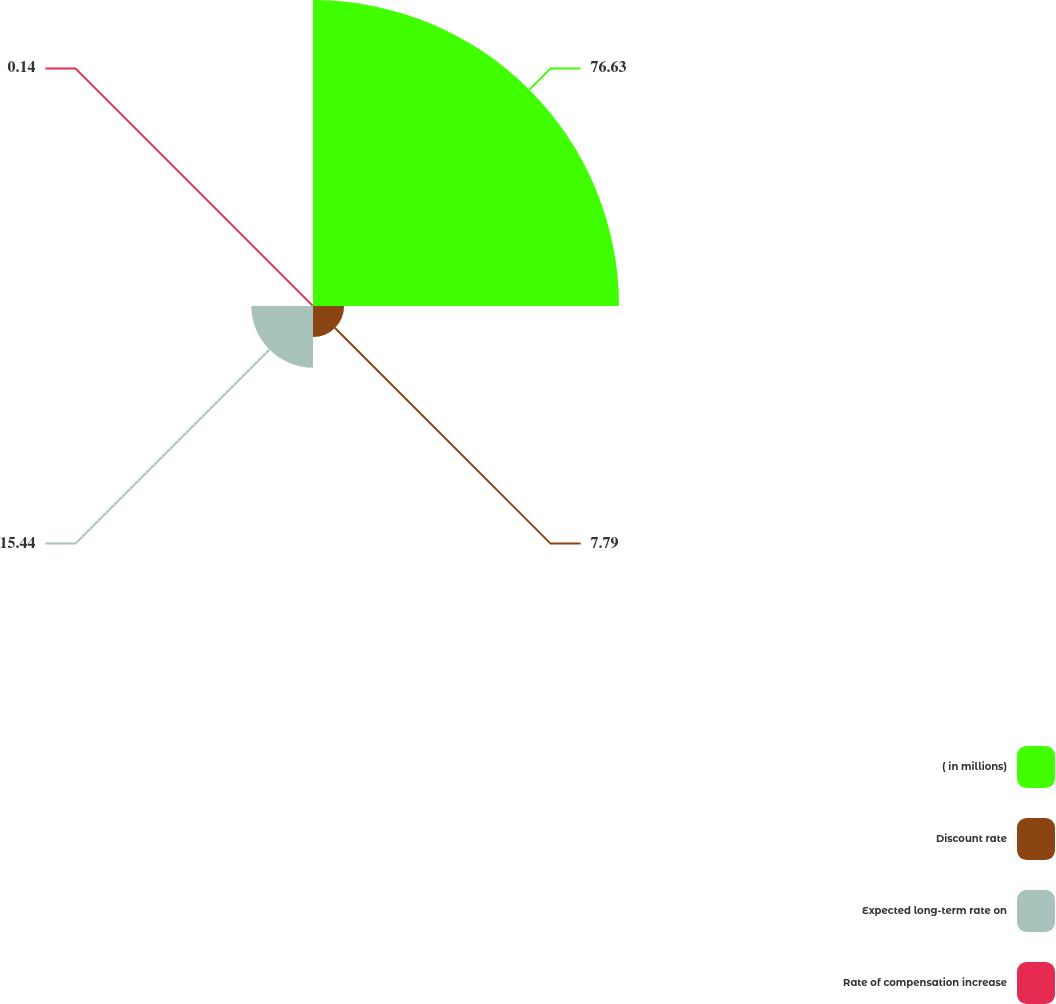<chart> <loc_0><loc_0><loc_500><loc_500><pie_chart><fcel>( in millions)<fcel>Discount rate<fcel>Expected long-term rate on<fcel>Rate of compensation increase<nl><fcel>76.63%<fcel>7.79%<fcel>15.44%<fcel>0.14%<nl></chart> 